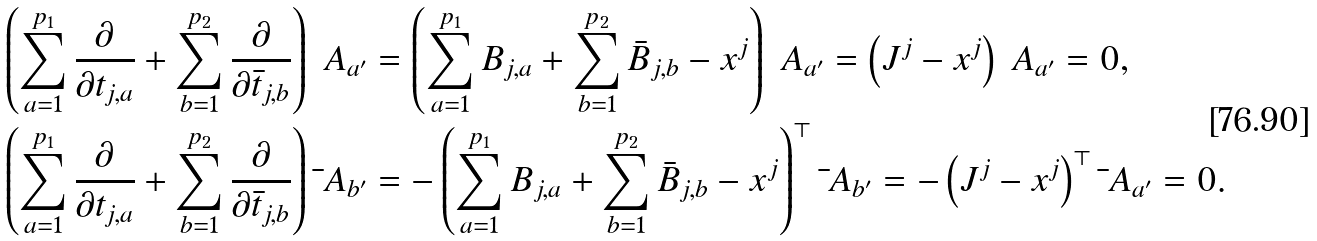<formula> <loc_0><loc_0><loc_500><loc_500>\left ( \sum _ { a = 1 } ^ { p _ { 1 } } \frac { \partial } { \partial t _ { j , a } } + \sum _ { b = 1 } ^ { p _ { 2 } } \frac { \partial } { \partial \bar { t } _ { j , b } } \right ) \ A _ { a ^ { \prime } } & = \left ( \sum _ { a = 1 } ^ { p _ { 1 } } B _ { j , a } + \sum _ { b = 1 } ^ { p _ { 2 } } \bar { B } _ { j , b } - x ^ { j } \right ) \ A _ { a ^ { \prime } } = \left ( J ^ { j } - x ^ { j } \right ) \ A _ { a ^ { \prime } } = 0 , \\ \left ( \sum _ { a = 1 } ^ { p _ { 1 } } \frac { \partial } { \partial t _ { j , a } } + \sum _ { b = 1 } ^ { p _ { 2 } } \frac { \partial } { \partial \bar { t } _ { j , b } } \right ) \bar { \ } A _ { b ^ { \prime } } & = - \left ( \sum _ { a = 1 } ^ { p _ { 1 } } B _ { j , a } + \sum _ { b = 1 } ^ { p _ { 2 } } \bar { B } _ { j , b } - x ^ { j } \right ) ^ { \top } \bar { \ } A _ { b ^ { \prime } } = - \left ( J ^ { j } - x ^ { j } \right ) ^ { \top } \bar { \ } A _ { a ^ { \prime } } = 0 .</formula> 